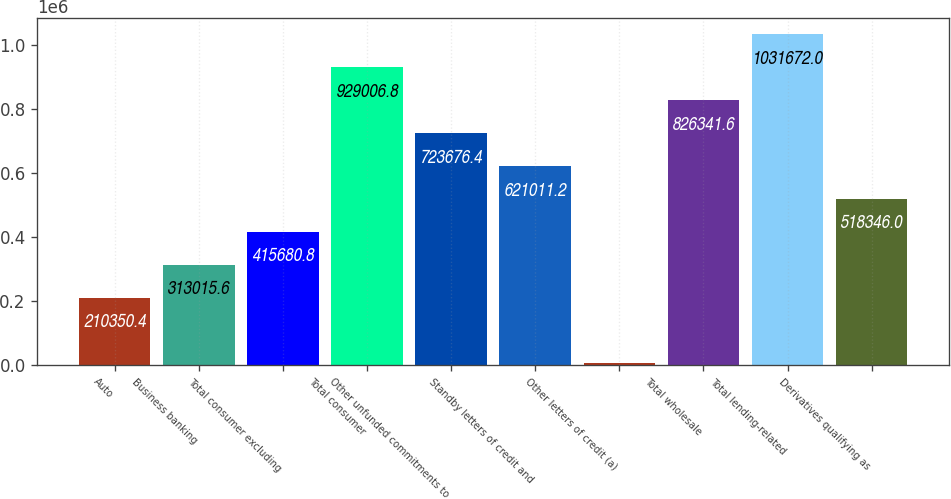Convert chart. <chart><loc_0><loc_0><loc_500><loc_500><bar_chart><fcel>Auto<fcel>Business banking<fcel>Total consumer excluding<fcel>Total consumer<fcel>Other unfunded commitments to<fcel>Standby letters of credit and<fcel>Other letters of credit (a)<fcel>Total wholesale<fcel>Total lending-related<fcel>Derivatives qualifying as<nl><fcel>210350<fcel>313016<fcel>415681<fcel>929007<fcel>723676<fcel>621011<fcel>5020<fcel>826342<fcel>1.03167e+06<fcel>518346<nl></chart> 